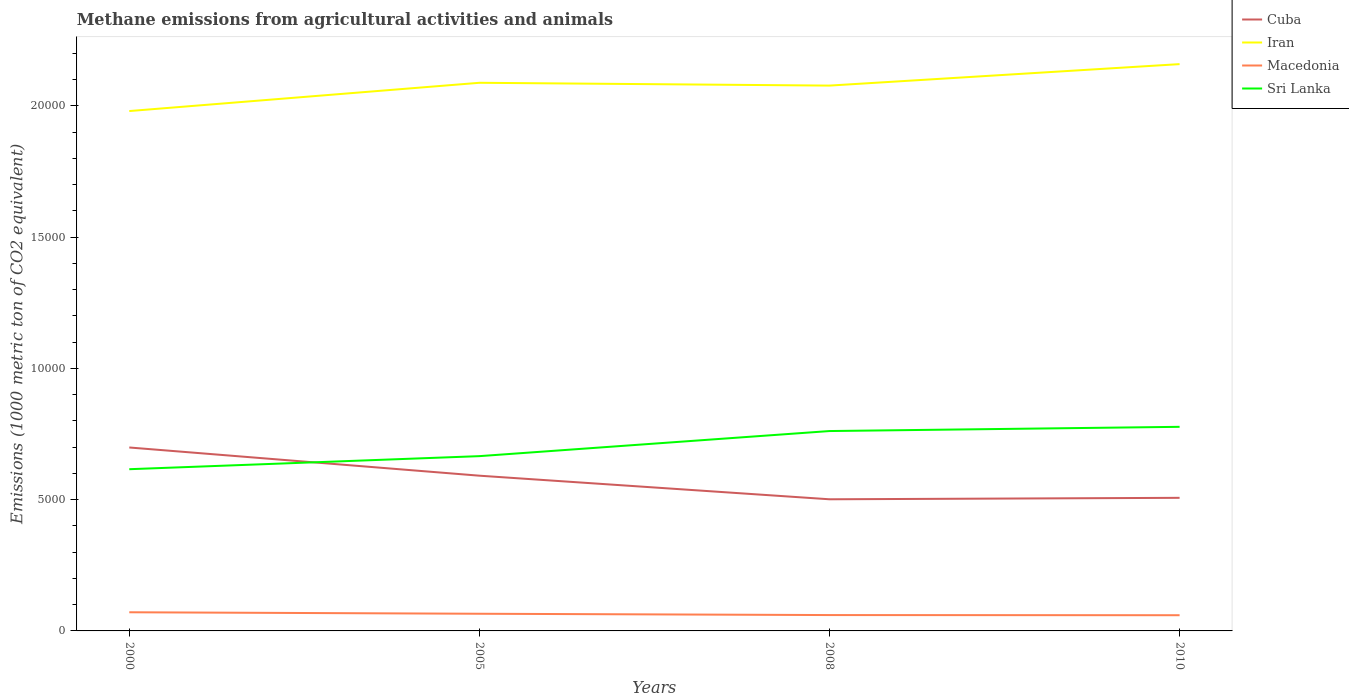Across all years, what is the maximum amount of methane emitted in Iran?
Your response must be concise. 1.98e+04. What is the total amount of methane emitted in Iran in the graph?
Offer a very short reply. -817.5. What is the difference between the highest and the second highest amount of methane emitted in Macedonia?
Offer a terse response. 112.6. What is the difference between the highest and the lowest amount of methane emitted in Iran?
Give a very brief answer. 3. Is the amount of methane emitted in Cuba strictly greater than the amount of methane emitted in Macedonia over the years?
Give a very brief answer. No. How many lines are there?
Make the answer very short. 4. How many years are there in the graph?
Keep it short and to the point. 4. Are the values on the major ticks of Y-axis written in scientific E-notation?
Make the answer very short. No. Does the graph contain any zero values?
Provide a short and direct response. No. Where does the legend appear in the graph?
Provide a succinct answer. Top right. How many legend labels are there?
Offer a terse response. 4. What is the title of the graph?
Your answer should be very brief. Methane emissions from agricultural activities and animals. What is the label or title of the Y-axis?
Make the answer very short. Emissions (1000 metric ton of CO2 equivalent). What is the Emissions (1000 metric ton of CO2 equivalent) of Cuba in 2000?
Offer a terse response. 6988.3. What is the Emissions (1000 metric ton of CO2 equivalent) in Iran in 2000?
Make the answer very short. 1.98e+04. What is the Emissions (1000 metric ton of CO2 equivalent) of Macedonia in 2000?
Make the answer very short. 710.8. What is the Emissions (1000 metric ton of CO2 equivalent) of Sri Lanka in 2000?
Offer a terse response. 6161. What is the Emissions (1000 metric ton of CO2 equivalent) in Cuba in 2005?
Your response must be concise. 5913.8. What is the Emissions (1000 metric ton of CO2 equivalent) in Iran in 2005?
Provide a succinct answer. 2.09e+04. What is the Emissions (1000 metric ton of CO2 equivalent) of Macedonia in 2005?
Your answer should be compact. 654.4. What is the Emissions (1000 metric ton of CO2 equivalent) of Sri Lanka in 2005?
Offer a very short reply. 6658.4. What is the Emissions (1000 metric ton of CO2 equivalent) in Cuba in 2008?
Make the answer very short. 5015. What is the Emissions (1000 metric ton of CO2 equivalent) in Iran in 2008?
Keep it short and to the point. 2.08e+04. What is the Emissions (1000 metric ton of CO2 equivalent) of Macedonia in 2008?
Keep it short and to the point. 603.9. What is the Emissions (1000 metric ton of CO2 equivalent) in Sri Lanka in 2008?
Ensure brevity in your answer.  7614.5. What is the Emissions (1000 metric ton of CO2 equivalent) of Cuba in 2010?
Your answer should be compact. 5070.2. What is the Emissions (1000 metric ton of CO2 equivalent) of Iran in 2010?
Give a very brief answer. 2.16e+04. What is the Emissions (1000 metric ton of CO2 equivalent) in Macedonia in 2010?
Offer a terse response. 598.2. What is the Emissions (1000 metric ton of CO2 equivalent) in Sri Lanka in 2010?
Give a very brief answer. 7775.6. Across all years, what is the maximum Emissions (1000 metric ton of CO2 equivalent) in Cuba?
Ensure brevity in your answer.  6988.3. Across all years, what is the maximum Emissions (1000 metric ton of CO2 equivalent) of Iran?
Your response must be concise. 2.16e+04. Across all years, what is the maximum Emissions (1000 metric ton of CO2 equivalent) in Macedonia?
Provide a succinct answer. 710.8. Across all years, what is the maximum Emissions (1000 metric ton of CO2 equivalent) in Sri Lanka?
Offer a terse response. 7775.6. Across all years, what is the minimum Emissions (1000 metric ton of CO2 equivalent) of Cuba?
Provide a short and direct response. 5015. Across all years, what is the minimum Emissions (1000 metric ton of CO2 equivalent) of Iran?
Provide a succinct answer. 1.98e+04. Across all years, what is the minimum Emissions (1000 metric ton of CO2 equivalent) in Macedonia?
Your response must be concise. 598.2. Across all years, what is the minimum Emissions (1000 metric ton of CO2 equivalent) in Sri Lanka?
Your answer should be very brief. 6161. What is the total Emissions (1000 metric ton of CO2 equivalent) in Cuba in the graph?
Make the answer very short. 2.30e+04. What is the total Emissions (1000 metric ton of CO2 equivalent) of Iran in the graph?
Give a very brief answer. 8.31e+04. What is the total Emissions (1000 metric ton of CO2 equivalent) of Macedonia in the graph?
Offer a terse response. 2567.3. What is the total Emissions (1000 metric ton of CO2 equivalent) of Sri Lanka in the graph?
Ensure brevity in your answer.  2.82e+04. What is the difference between the Emissions (1000 metric ton of CO2 equivalent) of Cuba in 2000 and that in 2005?
Ensure brevity in your answer.  1074.5. What is the difference between the Emissions (1000 metric ton of CO2 equivalent) in Iran in 2000 and that in 2005?
Provide a short and direct response. -1076.9. What is the difference between the Emissions (1000 metric ton of CO2 equivalent) in Macedonia in 2000 and that in 2005?
Provide a short and direct response. 56.4. What is the difference between the Emissions (1000 metric ton of CO2 equivalent) of Sri Lanka in 2000 and that in 2005?
Make the answer very short. -497.4. What is the difference between the Emissions (1000 metric ton of CO2 equivalent) in Cuba in 2000 and that in 2008?
Keep it short and to the point. 1973.3. What is the difference between the Emissions (1000 metric ton of CO2 equivalent) of Iran in 2000 and that in 2008?
Give a very brief answer. -970.2. What is the difference between the Emissions (1000 metric ton of CO2 equivalent) in Macedonia in 2000 and that in 2008?
Give a very brief answer. 106.9. What is the difference between the Emissions (1000 metric ton of CO2 equivalent) of Sri Lanka in 2000 and that in 2008?
Offer a terse response. -1453.5. What is the difference between the Emissions (1000 metric ton of CO2 equivalent) in Cuba in 2000 and that in 2010?
Offer a terse response. 1918.1. What is the difference between the Emissions (1000 metric ton of CO2 equivalent) of Iran in 2000 and that in 2010?
Provide a succinct answer. -1787.7. What is the difference between the Emissions (1000 metric ton of CO2 equivalent) in Macedonia in 2000 and that in 2010?
Provide a succinct answer. 112.6. What is the difference between the Emissions (1000 metric ton of CO2 equivalent) of Sri Lanka in 2000 and that in 2010?
Your answer should be compact. -1614.6. What is the difference between the Emissions (1000 metric ton of CO2 equivalent) in Cuba in 2005 and that in 2008?
Make the answer very short. 898.8. What is the difference between the Emissions (1000 metric ton of CO2 equivalent) in Iran in 2005 and that in 2008?
Offer a terse response. 106.7. What is the difference between the Emissions (1000 metric ton of CO2 equivalent) of Macedonia in 2005 and that in 2008?
Your response must be concise. 50.5. What is the difference between the Emissions (1000 metric ton of CO2 equivalent) of Sri Lanka in 2005 and that in 2008?
Offer a terse response. -956.1. What is the difference between the Emissions (1000 metric ton of CO2 equivalent) in Cuba in 2005 and that in 2010?
Ensure brevity in your answer.  843.6. What is the difference between the Emissions (1000 metric ton of CO2 equivalent) of Iran in 2005 and that in 2010?
Ensure brevity in your answer.  -710.8. What is the difference between the Emissions (1000 metric ton of CO2 equivalent) in Macedonia in 2005 and that in 2010?
Provide a short and direct response. 56.2. What is the difference between the Emissions (1000 metric ton of CO2 equivalent) of Sri Lanka in 2005 and that in 2010?
Provide a short and direct response. -1117.2. What is the difference between the Emissions (1000 metric ton of CO2 equivalent) of Cuba in 2008 and that in 2010?
Make the answer very short. -55.2. What is the difference between the Emissions (1000 metric ton of CO2 equivalent) in Iran in 2008 and that in 2010?
Keep it short and to the point. -817.5. What is the difference between the Emissions (1000 metric ton of CO2 equivalent) in Sri Lanka in 2008 and that in 2010?
Keep it short and to the point. -161.1. What is the difference between the Emissions (1000 metric ton of CO2 equivalent) of Cuba in 2000 and the Emissions (1000 metric ton of CO2 equivalent) of Iran in 2005?
Keep it short and to the point. -1.39e+04. What is the difference between the Emissions (1000 metric ton of CO2 equivalent) of Cuba in 2000 and the Emissions (1000 metric ton of CO2 equivalent) of Macedonia in 2005?
Offer a terse response. 6333.9. What is the difference between the Emissions (1000 metric ton of CO2 equivalent) in Cuba in 2000 and the Emissions (1000 metric ton of CO2 equivalent) in Sri Lanka in 2005?
Make the answer very short. 329.9. What is the difference between the Emissions (1000 metric ton of CO2 equivalent) of Iran in 2000 and the Emissions (1000 metric ton of CO2 equivalent) of Macedonia in 2005?
Offer a terse response. 1.92e+04. What is the difference between the Emissions (1000 metric ton of CO2 equivalent) in Iran in 2000 and the Emissions (1000 metric ton of CO2 equivalent) in Sri Lanka in 2005?
Your answer should be compact. 1.31e+04. What is the difference between the Emissions (1000 metric ton of CO2 equivalent) of Macedonia in 2000 and the Emissions (1000 metric ton of CO2 equivalent) of Sri Lanka in 2005?
Your response must be concise. -5947.6. What is the difference between the Emissions (1000 metric ton of CO2 equivalent) of Cuba in 2000 and the Emissions (1000 metric ton of CO2 equivalent) of Iran in 2008?
Keep it short and to the point. -1.38e+04. What is the difference between the Emissions (1000 metric ton of CO2 equivalent) in Cuba in 2000 and the Emissions (1000 metric ton of CO2 equivalent) in Macedonia in 2008?
Offer a terse response. 6384.4. What is the difference between the Emissions (1000 metric ton of CO2 equivalent) in Cuba in 2000 and the Emissions (1000 metric ton of CO2 equivalent) in Sri Lanka in 2008?
Provide a succinct answer. -626.2. What is the difference between the Emissions (1000 metric ton of CO2 equivalent) of Iran in 2000 and the Emissions (1000 metric ton of CO2 equivalent) of Macedonia in 2008?
Keep it short and to the point. 1.92e+04. What is the difference between the Emissions (1000 metric ton of CO2 equivalent) of Iran in 2000 and the Emissions (1000 metric ton of CO2 equivalent) of Sri Lanka in 2008?
Your answer should be very brief. 1.22e+04. What is the difference between the Emissions (1000 metric ton of CO2 equivalent) in Macedonia in 2000 and the Emissions (1000 metric ton of CO2 equivalent) in Sri Lanka in 2008?
Give a very brief answer. -6903.7. What is the difference between the Emissions (1000 metric ton of CO2 equivalent) in Cuba in 2000 and the Emissions (1000 metric ton of CO2 equivalent) in Iran in 2010?
Your answer should be compact. -1.46e+04. What is the difference between the Emissions (1000 metric ton of CO2 equivalent) in Cuba in 2000 and the Emissions (1000 metric ton of CO2 equivalent) in Macedonia in 2010?
Offer a terse response. 6390.1. What is the difference between the Emissions (1000 metric ton of CO2 equivalent) of Cuba in 2000 and the Emissions (1000 metric ton of CO2 equivalent) of Sri Lanka in 2010?
Your answer should be very brief. -787.3. What is the difference between the Emissions (1000 metric ton of CO2 equivalent) of Iran in 2000 and the Emissions (1000 metric ton of CO2 equivalent) of Macedonia in 2010?
Offer a very short reply. 1.92e+04. What is the difference between the Emissions (1000 metric ton of CO2 equivalent) in Iran in 2000 and the Emissions (1000 metric ton of CO2 equivalent) in Sri Lanka in 2010?
Make the answer very short. 1.20e+04. What is the difference between the Emissions (1000 metric ton of CO2 equivalent) in Macedonia in 2000 and the Emissions (1000 metric ton of CO2 equivalent) in Sri Lanka in 2010?
Make the answer very short. -7064.8. What is the difference between the Emissions (1000 metric ton of CO2 equivalent) in Cuba in 2005 and the Emissions (1000 metric ton of CO2 equivalent) in Iran in 2008?
Ensure brevity in your answer.  -1.49e+04. What is the difference between the Emissions (1000 metric ton of CO2 equivalent) in Cuba in 2005 and the Emissions (1000 metric ton of CO2 equivalent) in Macedonia in 2008?
Your answer should be compact. 5309.9. What is the difference between the Emissions (1000 metric ton of CO2 equivalent) of Cuba in 2005 and the Emissions (1000 metric ton of CO2 equivalent) of Sri Lanka in 2008?
Your response must be concise. -1700.7. What is the difference between the Emissions (1000 metric ton of CO2 equivalent) of Iran in 2005 and the Emissions (1000 metric ton of CO2 equivalent) of Macedonia in 2008?
Offer a terse response. 2.03e+04. What is the difference between the Emissions (1000 metric ton of CO2 equivalent) in Iran in 2005 and the Emissions (1000 metric ton of CO2 equivalent) in Sri Lanka in 2008?
Your response must be concise. 1.33e+04. What is the difference between the Emissions (1000 metric ton of CO2 equivalent) of Macedonia in 2005 and the Emissions (1000 metric ton of CO2 equivalent) of Sri Lanka in 2008?
Provide a short and direct response. -6960.1. What is the difference between the Emissions (1000 metric ton of CO2 equivalent) of Cuba in 2005 and the Emissions (1000 metric ton of CO2 equivalent) of Iran in 2010?
Give a very brief answer. -1.57e+04. What is the difference between the Emissions (1000 metric ton of CO2 equivalent) of Cuba in 2005 and the Emissions (1000 metric ton of CO2 equivalent) of Macedonia in 2010?
Offer a terse response. 5315.6. What is the difference between the Emissions (1000 metric ton of CO2 equivalent) in Cuba in 2005 and the Emissions (1000 metric ton of CO2 equivalent) in Sri Lanka in 2010?
Ensure brevity in your answer.  -1861.8. What is the difference between the Emissions (1000 metric ton of CO2 equivalent) of Iran in 2005 and the Emissions (1000 metric ton of CO2 equivalent) of Macedonia in 2010?
Give a very brief answer. 2.03e+04. What is the difference between the Emissions (1000 metric ton of CO2 equivalent) in Iran in 2005 and the Emissions (1000 metric ton of CO2 equivalent) in Sri Lanka in 2010?
Provide a short and direct response. 1.31e+04. What is the difference between the Emissions (1000 metric ton of CO2 equivalent) in Macedonia in 2005 and the Emissions (1000 metric ton of CO2 equivalent) in Sri Lanka in 2010?
Give a very brief answer. -7121.2. What is the difference between the Emissions (1000 metric ton of CO2 equivalent) of Cuba in 2008 and the Emissions (1000 metric ton of CO2 equivalent) of Iran in 2010?
Provide a succinct answer. -1.66e+04. What is the difference between the Emissions (1000 metric ton of CO2 equivalent) in Cuba in 2008 and the Emissions (1000 metric ton of CO2 equivalent) in Macedonia in 2010?
Your answer should be compact. 4416.8. What is the difference between the Emissions (1000 metric ton of CO2 equivalent) in Cuba in 2008 and the Emissions (1000 metric ton of CO2 equivalent) in Sri Lanka in 2010?
Keep it short and to the point. -2760.6. What is the difference between the Emissions (1000 metric ton of CO2 equivalent) of Iran in 2008 and the Emissions (1000 metric ton of CO2 equivalent) of Macedonia in 2010?
Your answer should be compact. 2.02e+04. What is the difference between the Emissions (1000 metric ton of CO2 equivalent) of Iran in 2008 and the Emissions (1000 metric ton of CO2 equivalent) of Sri Lanka in 2010?
Make the answer very short. 1.30e+04. What is the difference between the Emissions (1000 metric ton of CO2 equivalent) of Macedonia in 2008 and the Emissions (1000 metric ton of CO2 equivalent) of Sri Lanka in 2010?
Provide a short and direct response. -7171.7. What is the average Emissions (1000 metric ton of CO2 equivalent) of Cuba per year?
Your answer should be compact. 5746.82. What is the average Emissions (1000 metric ton of CO2 equivalent) of Iran per year?
Give a very brief answer. 2.08e+04. What is the average Emissions (1000 metric ton of CO2 equivalent) of Macedonia per year?
Your answer should be compact. 641.83. What is the average Emissions (1000 metric ton of CO2 equivalent) of Sri Lanka per year?
Keep it short and to the point. 7052.38. In the year 2000, what is the difference between the Emissions (1000 metric ton of CO2 equivalent) in Cuba and Emissions (1000 metric ton of CO2 equivalent) in Iran?
Ensure brevity in your answer.  -1.28e+04. In the year 2000, what is the difference between the Emissions (1000 metric ton of CO2 equivalent) in Cuba and Emissions (1000 metric ton of CO2 equivalent) in Macedonia?
Make the answer very short. 6277.5. In the year 2000, what is the difference between the Emissions (1000 metric ton of CO2 equivalent) in Cuba and Emissions (1000 metric ton of CO2 equivalent) in Sri Lanka?
Offer a terse response. 827.3. In the year 2000, what is the difference between the Emissions (1000 metric ton of CO2 equivalent) of Iran and Emissions (1000 metric ton of CO2 equivalent) of Macedonia?
Ensure brevity in your answer.  1.91e+04. In the year 2000, what is the difference between the Emissions (1000 metric ton of CO2 equivalent) in Iran and Emissions (1000 metric ton of CO2 equivalent) in Sri Lanka?
Your answer should be very brief. 1.36e+04. In the year 2000, what is the difference between the Emissions (1000 metric ton of CO2 equivalent) in Macedonia and Emissions (1000 metric ton of CO2 equivalent) in Sri Lanka?
Keep it short and to the point. -5450.2. In the year 2005, what is the difference between the Emissions (1000 metric ton of CO2 equivalent) in Cuba and Emissions (1000 metric ton of CO2 equivalent) in Iran?
Provide a short and direct response. -1.50e+04. In the year 2005, what is the difference between the Emissions (1000 metric ton of CO2 equivalent) of Cuba and Emissions (1000 metric ton of CO2 equivalent) of Macedonia?
Offer a very short reply. 5259.4. In the year 2005, what is the difference between the Emissions (1000 metric ton of CO2 equivalent) in Cuba and Emissions (1000 metric ton of CO2 equivalent) in Sri Lanka?
Your response must be concise. -744.6. In the year 2005, what is the difference between the Emissions (1000 metric ton of CO2 equivalent) of Iran and Emissions (1000 metric ton of CO2 equivalent) of Macedonia?
Provide a succinct answer. 2.02e+04. In the year 2005, what is the difference between the Emissions (1000 metric ton of CO2 equivalent) of Iran and Emissions (1000 metric ton of CO2 equivalent) of Sri Lanka?
Offer a very short reply. 1.42e+04. In the year 2005, what is the difference between the Emissions (1000 metric ton of CO2 equivalent) of Macedonia and Emissions (1000 metric ton of CO2 equivalent) of Sri Lanka?
Provide a succinct answer. -6004. In the year 2008, what is the difference between the Emissions (1000 metric ton of CO2 equivalent) in Cuba and Emissions (1000 metric ton of CO2 equivalent) in Iran?
Keep it short and to the point. -1.58e+04. In the year 2008, what is the difference between the Emissions (1000 metric ton of CO2 equivalent) of Cuba and Emissions (1000 metric ton of CO2 equivalent) of Macedonia?
Offer a terse response. 4411.1. In the year 2008, what is the difference between the Emissions (1000 metric ton of CO2 equivalent) of Cuba and Emissions (1000 metric ton of CO2 equivalent) of Sri Lanka?
Your answer should be very brief. -2599.5. In the year 2008, what is the difference between the Emissions (1000 metric ton of CO2 equivalent) in Iran and Emissions (1000 metric ton of CO2 equivalent) in Macedonia?
Your answer should be very brief. 2.02e+04. In the year 2008, what is the difference between the Emissions (1000 metric ton of CO2 equivalent) in Iran and Emissions (1000 metric ton of CO2 equivalent) in Sri Lanka?
Ensure brevity in your answer.  1.32e+04. In the year 2008, what is the difference between the Emissions (1000 metric ton of CO2 equivalent) of Macedonia and Emissions (1000 metric ton of CO2 equivalent) of Sri Lanka?
Your answer should be compact. -7010.6. In the year 2010, what is the difference between the Emissions (1000 metric ton of CO2 equivalent) of Cuba and Emissions (1000 metric ton of CO2 equivalent) of Iran?
Give a very brief answer. -1.65e+04. In the year 2010, what is the difference between the Emissions (1000 metric ton of CO2 equivalent) in Cuba and Emissions (1000 metric ton of CO2 equivalent) in Macedonia?
Offer a very short reply. 4472. In the year 2010, what is the difference between the Emissions (1000 metric ton of CO2 equivalent) of Cuba and Emissions (1000 metric ton of CO2 equivalent) of Sri Lanka?
Your answer should be compact. -2705.4. In the year 2010, what is the difference between the Emissions (1000 metric ton of CO2 equivalent) in Iran and Emissions (1000 metric ton of CO2 equivalent) in Macedonia?
Offer a terse response. 2.10e+04. In the year 2010, what is the difference between the Emissions (1000 metric ton of CO2 equivalent) in Iran and Emissions (1000 metric ton of CO2 equivalent) in Sri Lanka?
Provide a short and direct response. 1.38e+04. In the year 2010, what is the difference between the Emissions (1000 metric ton of CO2 equivalent) in Macedonia and Emissions (1000 metric ton of CO2 equivalent) in Sri Lanka?
Make the answer very short. -7177.4. What is the ratio of the Emissions (1000 metric ton of CO2 equivalent) of Cuba in 2000 to that in 2005?
Your response must be concise. 1.18. What is the ratio of the Emissions (1000 metric ton of CO2 equivalent) in Iran in 2000 to that in 2005?
Make the answer very short. 0.95. What is the ratio of the Emissions (1000 metric ton of CO2 equivalent) of Macedonia in 2000 to that in 2005?
Give a very brief answer. 1.09. What is the ratio of the Emissions (1000 metric ton of CO2 equivalent) in Sri Lanka in 2000 to that in 2005?
Provide a succinct answer. 0.93. What is the ratio of the Emissions (1000 metric ton of CO2 equivalent) of Cuba in 2000 to that in 2008?
Offer a terse response. 1.39. What is the ratio of the Emissions (1000 metric ton of CO2 equivalent) in Iran in 2000 to that in 2008?
Offer a terse response. 0.95. What is the ratio of the Emissions (1000 metric ton of CO2 equivalent) in Macedonia in 2000 to that in 2008?
Offer a very short reply. 1.18. What is the ratio of the Emissions (1000 metric ton of CO2 equivalent) of Sri Lanka in 2000 to that in 2008?
Provide a short and direct response. 0.81. What is the ratio of the Emissions (1000 metric ton of CO2 equivalent) of Cuba in 2000 to that in 2010?
Your response must be concise. 1.38. What is the ratio of the Emissions (1000 metric ton of CO2 equivalent) in Iran in 2000 to that in 2010?
Give a very brief answer. 0.92. What is the ratio of the Emissions (1000 metric ton of CO2 equivalent) in Macedonia in 2000 to that in 2010?
Your response must be concise. 1.19. What is the ratio of the Emissions (1000 metric ton of CO2 equivalent) of Sri Lanka in 2000 to that in 2010?
Provide a succinct answer. 0.79. What is the ratio of the Emissions (1000 metric ton of CO2 equivalent) of Cuba in 2005 to that in 2008?
Keep it short and to the point. 1.18. What is the ratio of the Emissions (1000 metric ton of CO2 equivalent) of Macedonia in 2005 to that in 2008?
Make the answer very short. 1.08. What is the ratio of the Emissions (1000 metric ton of CO2 equivalent) of Sri Lanka in 2005 to that in 2008?
Give a very brief answer. 0.87. What is the ratio of the Emissions (1000 metric ton of CO2 equivalent) of Cuba in 2005 to that in 2010?
Offer a very short reply. 1.17. What is the ratio of the Emissions (1000 metric ton of CO2 equivalent) of Iran in 2005 to that in 2010?
Your response must be concise. 0.97. What is the ratio of the Emissions (1000 metric ton of CO2 equivalent) of Macedonia in 2005 to that in 2010?
Give a very brief answer. 1.09. What is the ratio of the Emissions (1000 metric ton of CO2 equivalent) of Sri Lanka in 2005 to that in 2010?
Keep it short and to the point. 0.86. What is the ratio of the Emissions (1000 metric ton of CO2 equivalent) in Cuba in 2008 to that in 2010?
Make the answer very short. 0.99. What is the ratio of the Emissions (1000 metric ton of CO2 equivalent) of Iran in 2008 to that in 2010?
Your response must be concise. 0.96. What is the ratio of the Emissions (1000 metric ton of CO2 equivalent) of Macedonia in 2008 to that in 2010?
Your response must be concise. 1.01. What is the ratio of the Emissions (1000 metric ton of CO2 equivalent) of Sri Lanka in 2008 to that in 2010?
Provide a succinct answer. 0.98. What is the difference between the highest and the second highest Emissions (1000 metric ton of CO2 equivalent) of Cuba?
Provide a succinct answer. 1074.5. What is the difference between the highest and the second highest Emissions (1000 metric ton of CO2 equivalent) of Iran?
Your answer should be compact. 710.8. What is the difference between the highest and the second highest Emissions (1000 metric ton of CO2 equivalent) of Macedonia?
Provide a short and direct response. 56.4. What is the difference between the highest and the second highest Emissions (1000 metric ton of CO2 equivalent) in Sri Lanka?
Ensure brevity in your answer.  161.1. What is the difference between the highest and the lowest Emissions (1000 metric ton of CO2 equivalent) in Cuba?
Your answer should be compact. 1973.3. What is the difference between the highest and the lowest Emissions (1000 metric ton of CO2 equivalent) in Iran?
Your answer should be compact. 1787.7. What is the difference between the highest and the lowest Emissions (1000 metric ton of CO2 equivalent) of Macedonia?
Keep it short and to the point. 112.6. What is the difference between the highest and the lowest Emissions (1000 metric ton of CO2 equivalent) of Sri Lanka?
Your answer should be compact. 1614.6. 